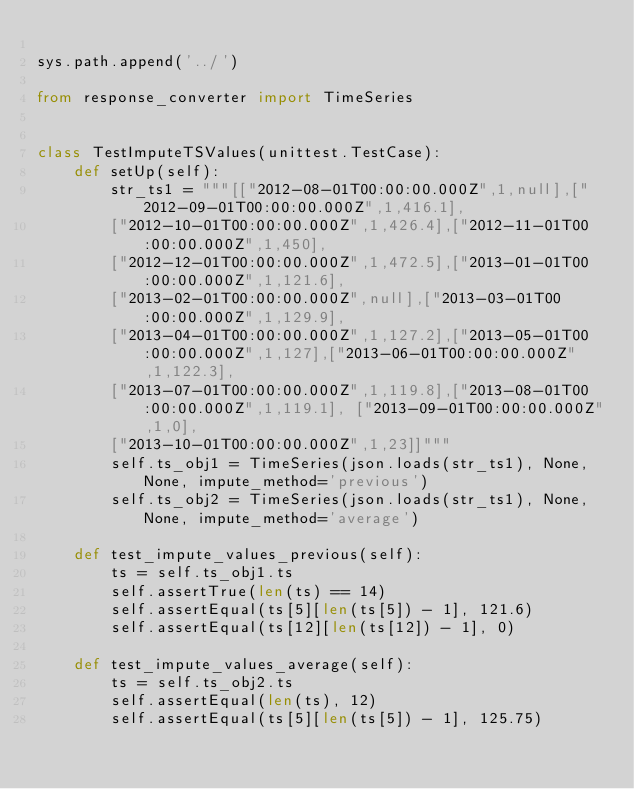<code> <loc_0><loc_0><loc_500><loc_500><_Python_>
sys.path.append('../')

from response_converter import TimeSeries


class TestImputeTSValues(unittest.TestCase):
    def setUp(self):
        str_ts1 = """[["2012-08-01T00:00:00.000Z",1,null],["2012-09-01T00:00:00.000Z",1,416.1],
        ["2012-10-01T00:00:00.000Z",1,426.4],["2012-11-01T00:00:00.000Z",1,450],
        ["2012-12-01T00:00:00.000Z",1,472.5],["2013-01-01T00:00:00.000Z",1,121.6],
        ["2013-02-01T00:00:00.000Z",null],["2013-03-01T00:00:00.000Z",1,129.9],
        ["2013-04-01T00:00:00.000Z",1,127.2],["2013-05-01T00:00:00.000Z",1,127],["2013-06-01T00:00:00.000Z",1,122.3],
        ["2013-07-01T00:00:00.000Z",1,119.8],["2013-08-01T00:00:00.000Z",1,119.1], ["2013-09-01T00:00:00.000Z",1,0], 
        ["2013-10-01T00:00:00.000Z",1,23]]"""
        self.ts_obj1 = TimeSeries(json.loads(str_ts1), None, None, impute_method='previous')
        self.ts_obj2 = TimeSeries(json.loads(str_ts1), None, None, impute_method='average')

    def test_impute_values_previous(self):
        ts = self.ts_obj1.ts
        self.assertTrue(len(ts) == 14)
        self.assertEqual(ts[5][len(ts[5]) - 1], 121.6)
        self.assertEqual(ts[12][len(ts[12]) - 1], 0)

    def test_impute_values_average(self):
        ts = self.ts_obj2.ts
        self.assertEqual(len(ts), 12)
        self.assertEqual(ts[5][len(ts[5]) - 1], 125.75)
</code> 